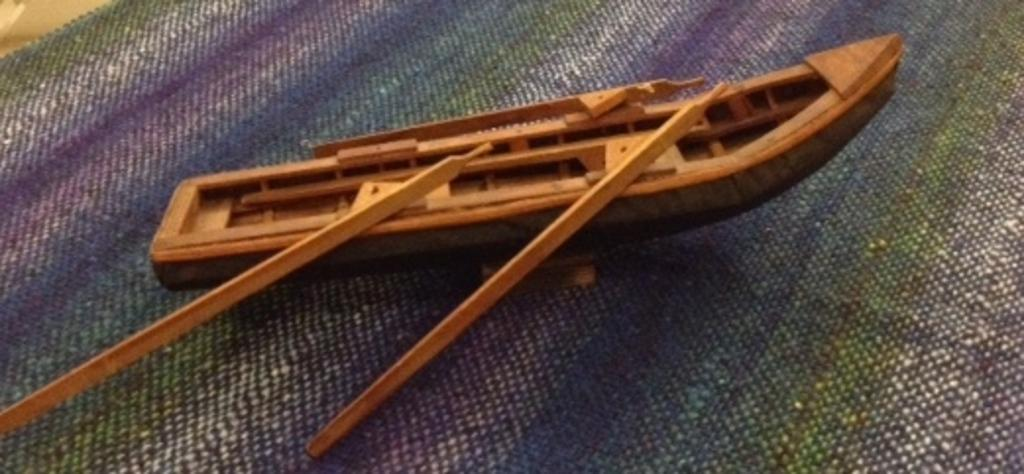What is the main subject of the picture? The main subject of the picture is a toy boat. How many rows does the toy boat have? The toy boat has two rows. Where is the toy boat located? The toy boat is on a blanket. What type of neck accessory is the toy boat wearing in the image? There is no neck accessory present on the toy boat in the image. How many hydrants are visible in the image? There are no hydrants present in the image; it features a toy boat on a blanket. 